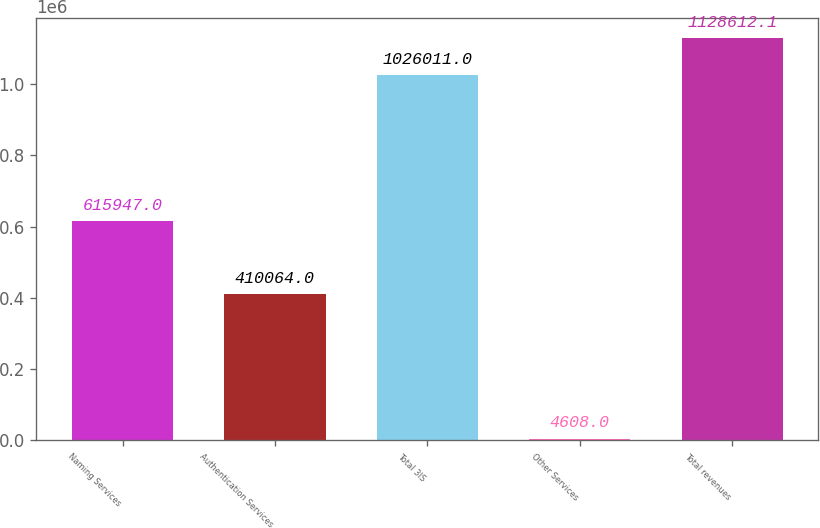<chart> <loc_0><loc_0><loc_500><loc_500><bar_chart><fcel>Naming Services<fcel>Authentication Services<fcel>Total 3IS<fcel>Other Services<fcel>Total revenues<nl><fcel>615947<fcel>410064<fcel>1.02601e+06<fcel>4608<fcel>1.12861e+06<nl></chart> 